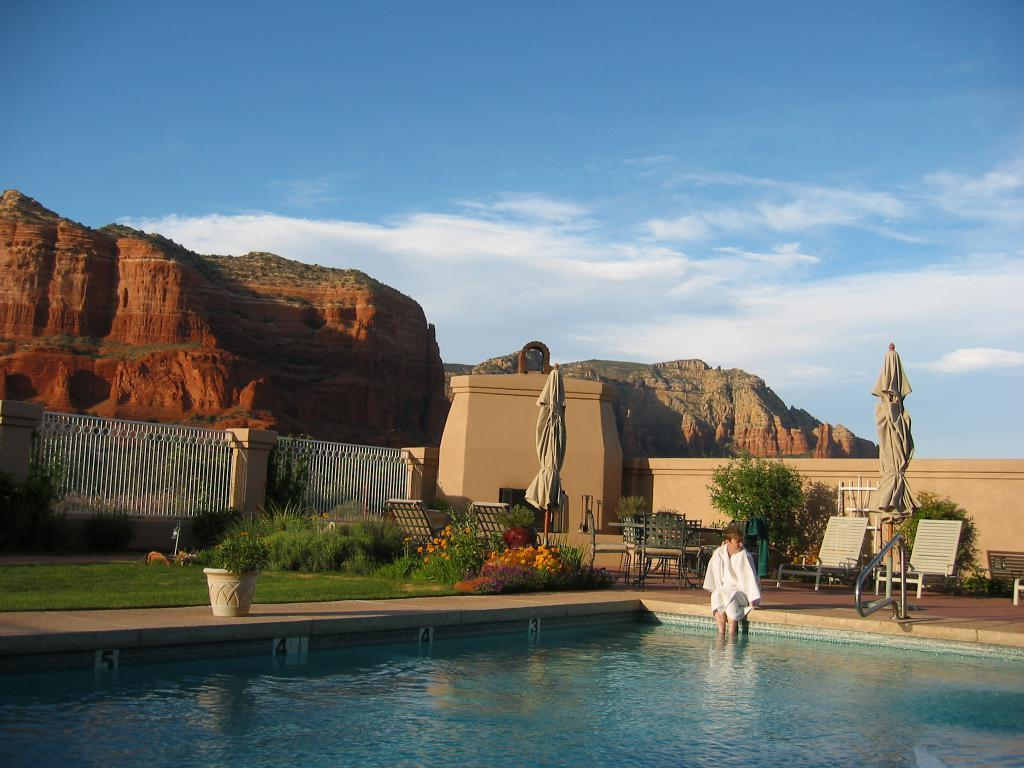What is the person doing in the image? The person is sitting outside a swimming pool with their legs in the water. What can be seen in the background of the image? There are many plants, flowers, and hills visible in the background. What type of instrument is the person playing in the image? There is no instrument present in the image; the person is simply sitting with their legs in the water. 